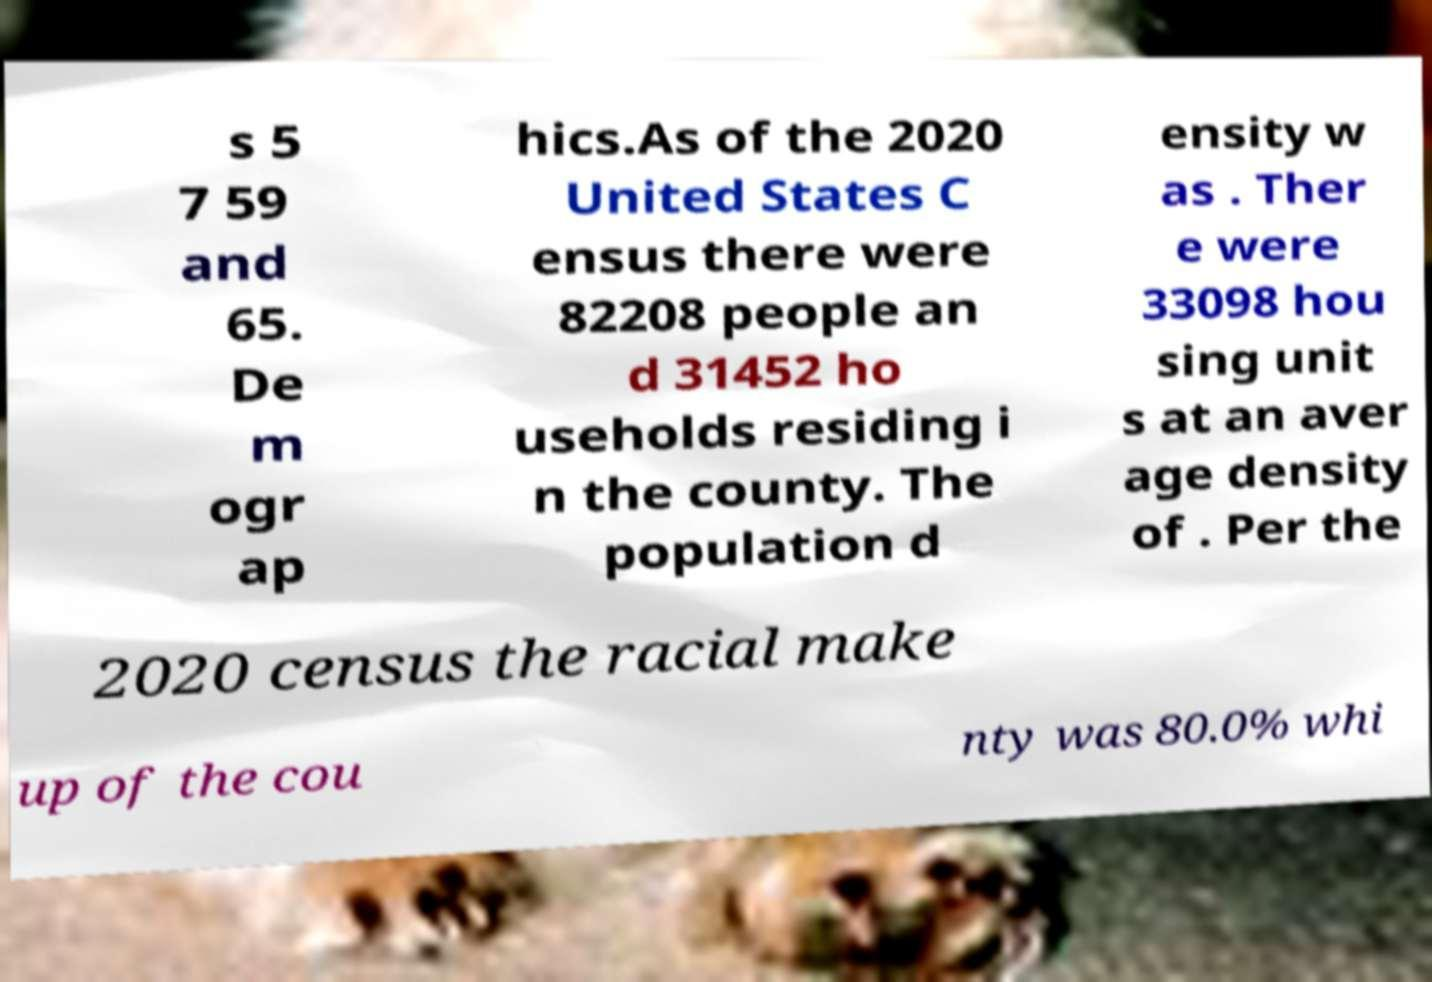Please identify and transcribe the text found in this image. s 5 7 59 and 65. De m ogr ap hics.As of the 2020 United States C ensus there were 82208 people an d 31452 ho useholds residing i n the county. The population d ensity w as . Ther e were 33098 hou sing unit s at an aver age density of . Per the 2020 census the racial make up of the cou nty was 80.0% whi 